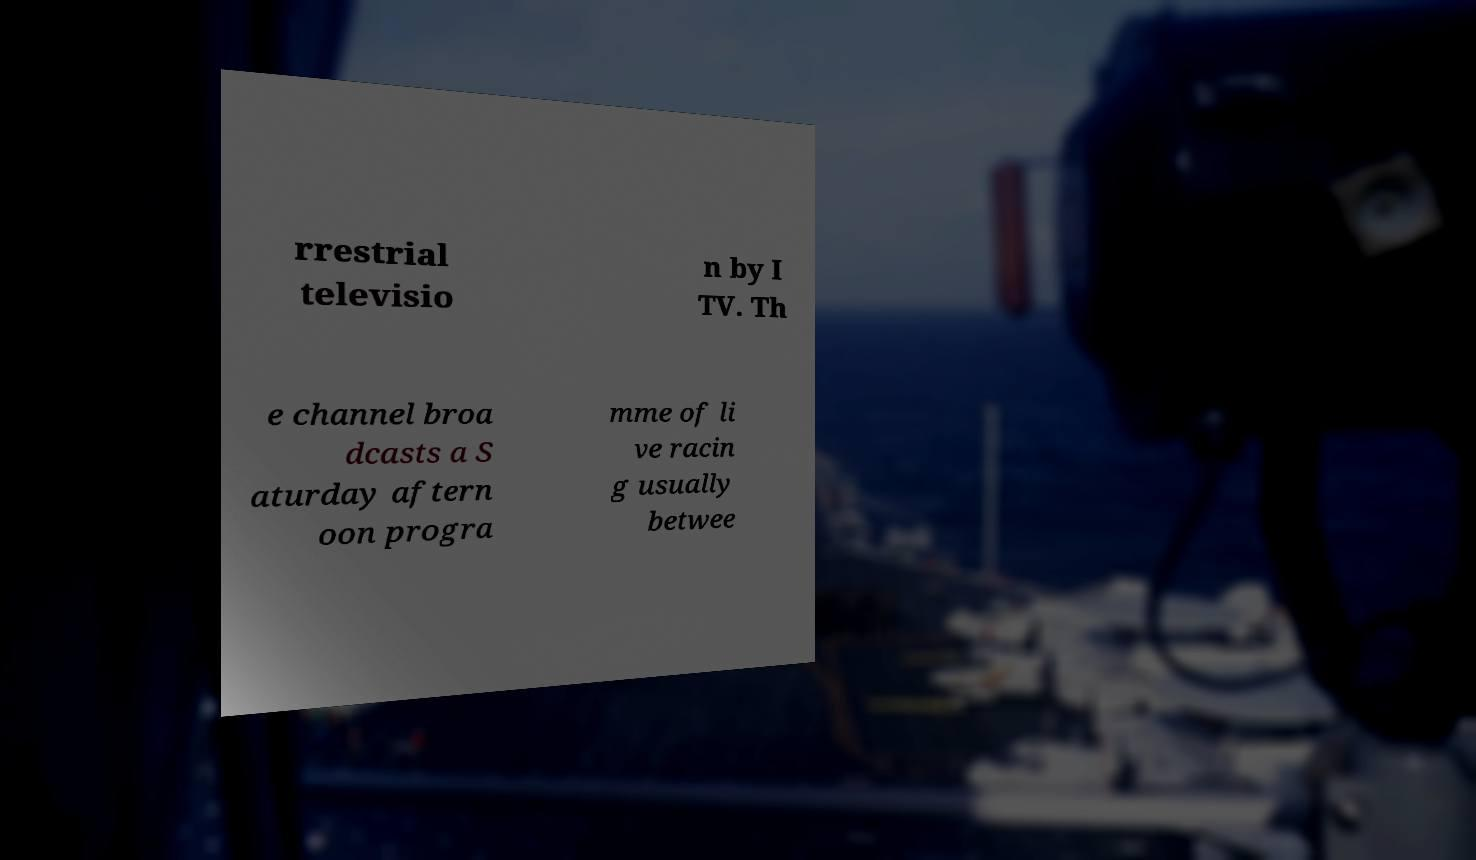Could you extract and type out the text from this image? rrestrial televisio n by I TV. Th e channel broa dcasts a S aturday aftern oon progra mme of li ve racin g usually betwee 